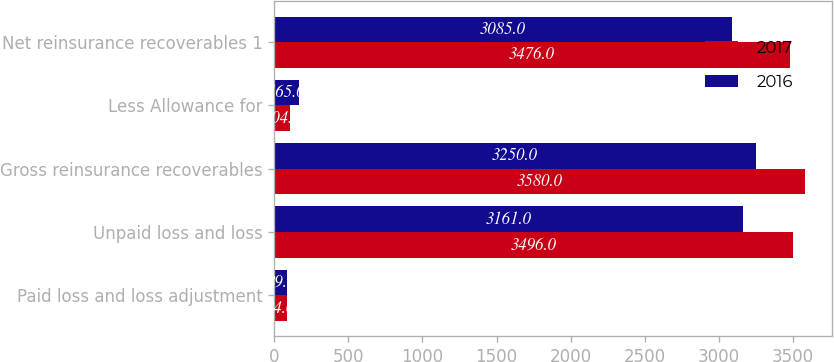Convert chart. <chart><loc_0><loc_0><loc_500><loc_500><stacked_bar_chart><ecel><fcel>Paid loss and loss adjustment<fcel>Unpaid loss and loss<fcel>Gross reinsurance recoverables<fcel>Less Allowance for<fcel>Net reinsurance recoverables 1<nl><fcel>2017<fcel>84<fcel>3496<fcel>3580<fcel>104<fcel>3476<nl><fcel>2016<fcel>89<fcel>3161<fcel>3250<fcel>165<fcel>3085<nl></chart> 